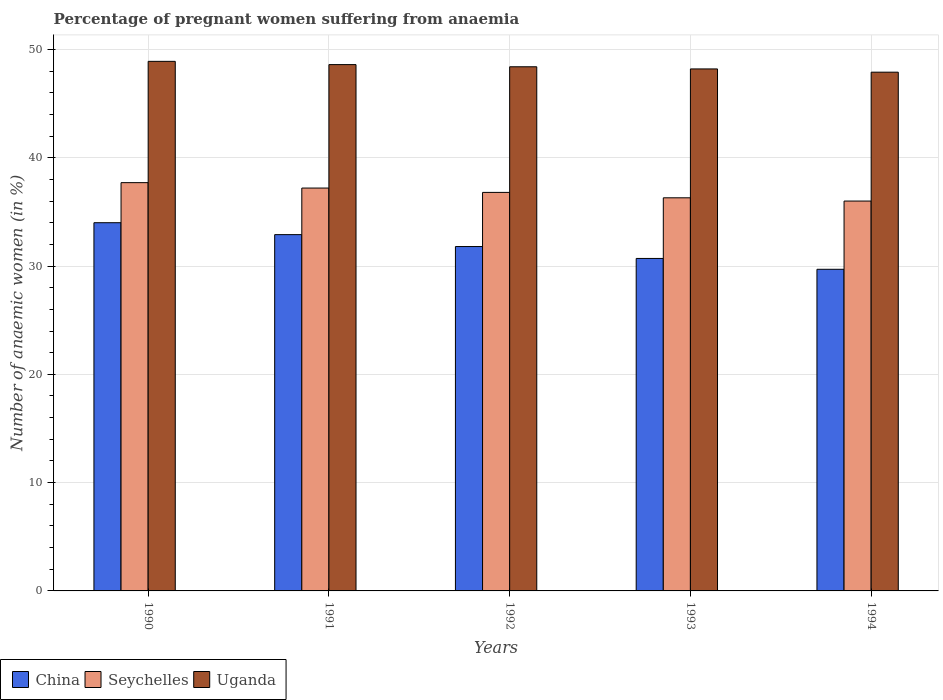Are the number of bars per tick equal to the number of legend labels?
Provide a succinct answer. Yes. Are the number of bars on each tick of the X-axis equal?
Offer a terse response. Yes. How many bars are there on the 4th tick from the left?
Your answer should be very brief. 3. What is the number of anaemic women in Uganda in 1994?
Give a very brief answer. 47.9. Across all years, what is the maximum number of anaemic women in Uganda?
Make the answer very short. 48.9. Across all years, what is the minimum number of anaemic women in China?
Keep it short and to the point. 29.7. In which year was the number of anaemic women in Uganda minimum?
Provide a succinct answer. 1994. What is the total number of anaemic women in Uganda in the graph?
Provide a short and direct response. 242. What is the difference between the number of anaemic women in Uganda in 1991 and that in 1994?
Give a very brief answer. 0.7. What is the difference between the number of anaemic women in Uganda in 1993 and the number of anaemic women in China in 1990?
Keep it short and to the point. 14.2. What is the average number of anaemic women in Uganda per year?
Your answer should be compact. 48.4. In the year 1991, what is the difference between the number of anaemic women in Seychelles and number of anaemic women in China?
Offer a terse response. 4.3. In how many years, is the number of anaemic women in China greater than 32 %?
Offer a terse response. 2. What is the ratio of the number of anaemic women in Seychelles in 1992 to that in 1993?
Your response must be concise. 1.01. Is the number of anaemic women in Seychelles in 1990 less than that in 1993?
Your response must be concise. No. Is the difference between the number of anaemic women in Seychelles in 1993 and 1994 greater than the difference between the number of anaemic women in China in 1993 and 1994?
Give a very brief answer. No. What is the difference between the highest and the second highest number of anaemic women in Uganda?
Provide a short and direct response. 0.3. What is the difference between the highest and the lowest number of anaemic women in China?
Your answer should be compact. 4.3. In how many years, is the number of anaemic women in Seychelles greater than the average number of anaemic women in Seychelles taken over all years?
Give a very brief answer. 2. Is the sum of the number of anaemic women in Uganda in 1990 and 1992 greater than the maximum number of anaemic women in China across all years?
Your response must be concise. Yes. What does the 2nd bar from the right in 1992 represents?
Offer a terse response. Seychelles. Is it the case that in every year, the sum of the number of anaemic women in Uganda and number of anaemic women in Seychelles is greater than the number of anaemic women in China?
Your response must be concise. Yes. How many bars are there?
Keep it short and to the point. 15. What is the difference between two consecutive major ticks on the Y-axis?
Provide a succinct answer. 10. Where does the legend appear in the graph?
Your answer should be compact. Bottom left. What is the title of the graph?
Your response must be concise. Percentage of pregnant women suffering from anaemia. What is the label or title of the X-axis?
Provide a succinct answer. Years. What is the label or title of the Y-axis?
Provide a succinct answer. Number of anaemic women (in %). What is the Number of anaemic women (in %) of Seychelles in 1990?
Provide a short and direct response. 37.7. What is the Number of anaemic women (in %) of Uganda in 1990?
Keep it short and to the point. 48.9. What is the Number of anaemic women (in %) of China in 1991?
Offer a terse response. 32.9. What is the Number of anaemic women (in %) in Seychelles in 1991?
Offer a terse response. 37.2. What is the Number of anaemic women (in %) in Uganda in 1991?
Your answer should be very brief. 48.6. What is the Number of anaemic women (in %) in China in 1992?
Make the answer very short. 31.8. What is the Number of anaemic women (in %) of Seychelles in 1992?
Make the answer very short. 36.8. What is the Number of anaemic women (in %) of Uganda in 1992?
Your response must be concise. 48.4. What is the Number of anaemic women (in %) in China in 1993?
Provide a succinct answer. 30.7. What is the Number of anaemic women (in %) of Seychelles in 1993?
Your answer should be very brief. 36.3. What is the Number of anaemic women (in %) in Uganda in 1993?
Your response must be concise. 48.2. What is the Number of anaemic women (in %) of China in 1994?
Provide a succinct answer. 29.7. What is the Number of anaemic women (in %) in Seychelles in 1994?
Provide a short and direct response. 36. What is the Number of anaemic women (in %) of Uganda in 1994?
Keep it short and to the point. 47.9. Across all years, what is the maximum Number of anaemic women (in %) of Seychelles?
Your response must be concise. 37.7. Across all years, what is the maximum Number of anaemic women (in %) in Uganda?
Offer a terse response. 48.9. Across all years, what is the minimum Number of anaemic women (in %) of China?
Your answer should be compact. 29.7. Across all years, what is the minimum Number of anaemic women (in %) of Seychelles?
Keep it short and to the point. 36. Across all years, what is the minimum Number of anaemic women (in %) in Uganda?
Your answer should be compact. 47.9. What is the total Number of anaemic women (in %) of China in the graph?
Offer a very short reply. 159.1. What is the total Number of anaemic women (in %) in Seychelles in the graph?
Make the answer very short. 184. What is the total Number of anaemic women (in %) of Uganda in the graph?
Provide a short and direct response. 242. What is the difference between the Number of anaemic women (in %) in China in 1990 and that in 1991?
Keep it short and to the point. 1.1. What is the difference between the Number of anaemic women (in %) of Seychelles in 1990 and that in 1991?
Provide a succinct answer. 0.5. What is the difference between the Number of anaemic women (in %) in China in 1990 and that in 1993?
Ensure brevity in your answer.  3.3. What is the difference between the Number of anaemic women (in %) in Seychelles in 1990 and that in 1993?
Keep it short and to the point. 1.4. What is the difference between the Number of anaemic women (in %) in Uganda in 1990 and that in 1993?
Your answer should be very brief. 0.7. What is the difference between the Number of anaemic women (in %) of Seychelles in 1991 and that in 1992?
Give a very brief answer. 0.4. What is the difference between the Number of anaemic women (in %) of Uganda in 1991 and that in 1992?
Your answer should be very brief. 0.2. What is the difference between the Number of anaemic women (in %) of Uganda in 1991 and that in 1993?
Offer a terse response. 0.4. What is the difference between the Number of anaemic women (in %) of China in 1991 and that in 1994?
Provide a succinct answer. 3.2. What is the difference between the Number of anaemic women (in %) in Seychelles in 1991 and that in 1994?
Provide a short and direct response. 1.2. What is the difference between the Number of anaemic women (in %) of Seychelles in 1992 and that in 1993?
Provide a succinct answer. 0.5. What is the difference between the Number of anaemic women (in %) of China in 1993 and that in 1994?
Provide a short and direct response. 1. What is the difference between the Number of anaemic women (in %) in Seychelles in 1993 and that in 1994?
Ensure brevity in your answer.  0.3. What is the difference between the Number of anaemic women (in %) in Uganda in 1993 and that in 1994?
Provide a short and direct response. 0.3. What is the difference between the Number of anaemic women (in %) in China in 1990 and the Number of anaemic women (in %) in Uganda in 1991?
Provide a short and direct response. -14.6. What is the difference between the Number of anaemic women (in %) in China in 1990 and the Number of anaemic women (in %) in Seychelles in 1992?
Ensure brevity in your answer.  -2.8. What is the difference between the Number of anaemic women (in %) of China in 1990 and the Number of anaemic women (in %) of Uganda in 1992?
Keep it short and to the point. -14.4. What is the difference between the Number of anaemic women (in %) in Seychelles in 1990 and the Number of anaemic women (in %) in Uganda in 1992?
Provide a succinct answer. -10.7. What is the difference between the Number of anaemic women (in %) in China in 1990 and the Number of anaemic women (in %) in Seychelles in 1993?
Make the answer very short. -2.3. What is the difference between the Number of anaemic women (in %) in China in 1990 and the Number of anaemic women (in %) in Seychelles in 1994?
Keep it short and to the point. -2. What is the difference between the Number of anaemic women (in %) of China in 1991 and the Number of anaemic women (in %) of Uganda in 1992?
Ensure brevity in your answer.  -15.5. What is the difference between the Number of anaemic women (in %) in Seychelles in 1991 and the Number of anaemic women (in %) in Uganda in 1992?
Provide a short and direct response. -11.2. What is the difference between the Number of anaemic women (in %) of China in 1991 and the Number of anaemic women (in %) of Uganda in 1993?
Offer a terse response. -15.3. What is the difference between the Number of anaemic women (in %) of Seychelles in 1991 and the Number of anaemic women (in %) of Uganda in 1993?
Offer a terse response. -11. What is the difference between the Number of anaemic women (in %) of China in 1991 and the Number of anaemic women (in %) of Uganda in 1994?
Give a very brief answer. -15. What is the difference between the Number of anaemic women (in %) in China in 1992 and the Number of anaemic women (in %) in Uganda in 1993?
Offer a very short reply. -16.4. What is the difference between the Number of anaemic women (in %) in China in 1992 and the Number of anaemic women (in %) in Uganda in 1994?
Keep it short and to the point. -16.1. What is the difference between the Number of anaemic women (in %) in Seychelles in 1992 and the Number of anaemic women (in %) in Uganda in 1994?
Give a very brief answer. -11.1. What is the difference between the Number of anaemic women (in %) of China in 1993 and the Number of anaemic women (in %) of Seychelles in 1994?
Your answer should be very brief. -5.3. What is the difference between the Number of anaemic women (in %) of China in 1993 and the Number of anaemic women (in %) of Uganda in 1994?
Ensure brevity in your answer.  -17.2. What is the average Number of anaemic women (in %) of China per year?
Provide a short and direct response. 31.82. What is the average Number of anaemic women (in %) of Seychelles per year?
Provide a short and direct response. 36.8. What is the average Number of anaemic women (in %) of Uganda per year?
Ensure brevity in your answer.  48.4. In the year 1990, what is the difference between the Number of anaemic women (in %) of China and Number of anaemic women (in %) of Uganda?
Make the answer very short. -14.9. In the year 1990, what is the difference between the Number of anaemic women (in %) of Seychelles and Number of anaemic women (in %) of Uganda?
Provide a short and direct response. -11.2. In the year 1991, what is the difference between the Number of anaemic women (in %) of China and Number of anaemic women (in %) of Uganda?
Keep it short and to the point. -15.7. In the year 1992, what is the difference between the Number of anaemic women (in %) in China and Number of anaemic women (in %) in Seychelles?
Keep it short and to the point. -5. In the year 1992, what is the difference between the Number of anaemic women (in %) in China and Number of anaemic women (in %) in Uganda?
Your answer should be compact. -16.6. In the year 1993, what is the difference between the Number of anaemic women (in %) of China and Number of anaemic women (in %) of Seychelles?
Provide a succinct answer. -5.6. In the year 1993, what is the difference between the Number of anaemic women (in %) of China and Number of anaemic women (in %) of Uganda?
Offer a terse response. -17.5. In the year 1994, what is the difference between the Number of anaemic women (in %) of China and Number of anaemic women (in %) of Seychelles?
Your answer should be very brief. -6.3. In the year 1994, what is the difference between the Number of anaemic women (in %) in China and Number of anaemic women (in %) in Uganda?
Offer a terse response. -18.2. In the year 1994, what is the difference between the Number of anaemic women (in %) in Seychelles and Number of anaemic women (in %) in Uganda?
Provide a succinct answer. -11.9. What is the ratio of the Number of anaemic women (in %) in China in 1990 to that in 1991?
Provide a short and direct response. 1.03. What is the ratio of the Number of anaemic women (in %) in Seychelles in 1990 to that in 1991?
Keep it short and to the point. 1.01. What is the ratio of the Number of anaemic women (in %) of Uganda in 1990 to that in 1991?
Provide a succinct answer. 1.01. What is the ratio of the Number of anaemic women (in %) in China in 1990 to that in 1992?
Your answer should be very brief. 1.07. What is the ratio of the Number of anaemic women (in %) of Seychelles in 1990 to that in 1992?
Keep it short and to the point. 1.02. What is the ratio of the Number of anaemic women (in %) in Uganda in 1990 to that in 1992?
Give a very brief answer. 1.01. What is the ratio of the Number of anaemic women (in %) in China in 1990 to that in 1993?
Ensure brevity in your answer.  1.11. What is the ratio of the Number of anaemic women (in %) of Seychelles in 1990 to that in 1993?
Your response must be concise. 1.04. What is the ratio of the Number of anaemic women (in %) in Uganda in 1990 to that in 1993?
Your answer should be very brief. 1.01. What is the ratio of the Number of anaemic women (in %) of China in 1990 to that in 1994?
Provide a succinct answer. 1.14. What is the ratio of the Number of anaemic women (in %) in Seychelles in 1990 to that in 1994?
Ensure brevity in your answer.  1.05. What is the ratio of the Number of anaemic women (in %) of Uganda in 1990 to that in 1994?
Give a very brief answer. 1.02. What is the ratio of the Number of anaemic women (in %) in China in 1991 to that in 1992?
Offer a very short reply. 1.03. What is the ratio of the Number of anaemic women (in %) of Seychelles in 1991 to that in 1992?
Provide a short and direct response. 1.01. What is the ratio of the Number of anaemic women (in %) of Uganda in 1991 to that in 1992?
Offer a terse response. 1. What is the ratio of the Number of anaemic women (in %) in China in 1991 to that in 1993?
Make the answer very short. 1.07. What is the ratio of the Number of anaemic women (in %) in Seychelles in 1991 to that in 1993?
Your answer should be very brief. 1.02. What is the ratio of the Number of anaemic women (in %) of Uganda in 1991 to that in 1993?
Your response must be concise. 1.01. What is the ratio of the Number of anaemic women (in %) in China in 1991 to that in 1994?
Provide a short and direct response. 1.11. What is the ratio of the Number of anaemic women (in %) of Uganda in 1991 to that in 1994?
Your answer should be very brief. 1.01. What is the ratio of the Number of anaemic women (in %) of China in 1992 to that in 1993?
Offer a very short reply. 1.04. What is the ratio of the Number of anaemic women (in %) in Seychelles in 1992 to that in 1993?
Your answer should be compact. 1.01. What is the ratio of the Number of anaemic women (in %) in Uganda in 1992 to that in 1993?
Your answer should be very brief. 1. What is the ratio of the Number of anaemic women (in %) in China in 1992 to that in 1994?
Give a very brief answer. 1.07. What is the ratio of the Number of anaemic women (in %) of Seychelles in 1992 to that in 1994?
Give a very brief answer. 1.02. What is the ratio of the Number of anaemic women (in %) of Uganda in 1992 to that in 1994?
Keep it short and to the point. 1.01. What is the ratio of the Number of anaemic women (in %) of China in 1993 to that in 1994?
Make the answer very short. 1.03. What is the ratio of the Number of anaemic women (in %) in Seychelles in 1993 to that in 1994?
Make the answer very short. 1.01. What is the ratio of the Number of anaemic women (in %) in Uganda in 1993 to that in 1994?
Provide a succinct answer. 1.01. What is the difference between the highest and the second highest Number of anaemic women (in %) of Seychelles?
Provide a succinct answer. 0.5. What is the difference between the highest and the lowest Number of anaemic women (in %) of China?
Make the answer very short. 4.3. What is the difference between the highest and the lowest Number of anaemic women (in %) in Seychelles?
Your answer should be very brief. 1.7. 